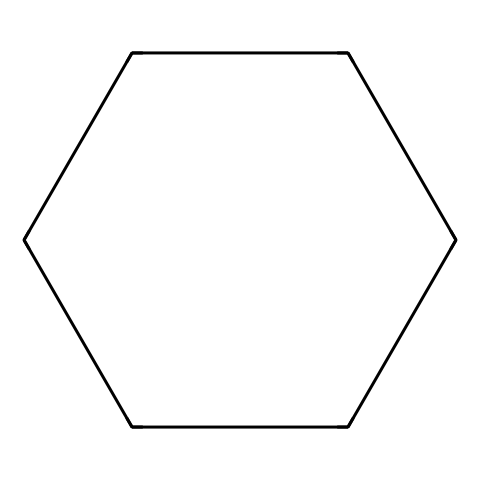How many carbon atoms are in cyclohexane? The SMILES representation "C1CCCCC1" indicates a cyclic structure with six carbon atoms, as each 'C' represents a carbon and they close the ring.
Answer: six What is the basic shape of cyclohexane in its chair conformation? In the chair conformation, cyclohexane adopts a 3D shape that resembles a chair, minimizing steric strain and torsional strain.
Answer: chair How many hydrogen atoms are bonded to cyclohexane? Each carbon atom in cyclohexane is bonded to two hydrogen atoms (as it is fully saturated), totaling twelve hydrogen atoms.
Answer: twelve Which conformation of cyclohexane is more stable: chair or boat? The chair conformation is lower in energy compared to the boat conformation due to less steric hindrance and more favorable bond angles, making it the more stable form.
Answer: chair What type of cycloalkane is represented by the SMILES C1CCCCC1? The structure shown is a cycloalkane, specifically a cyclohexane, because it contains a six-membered carbon ring and is saturated.
Answer: cyclohexane How does the energy of the boat conformation of cyclohexane compare to the chair conformation? The boat conformation has higher energy due to increased steric strain and torsional strain from eclipsing hydrogen atoms compared to the chair.
Answer: higher What feature in cyclohexane helps to achieve its stable chair conformation? The angles between the carbon-carbon bonds in the chair conformation are close to 109.5 degrees, closely matching the ideal tetrahedral angle, minimizing strain.
Answer: bond angles 